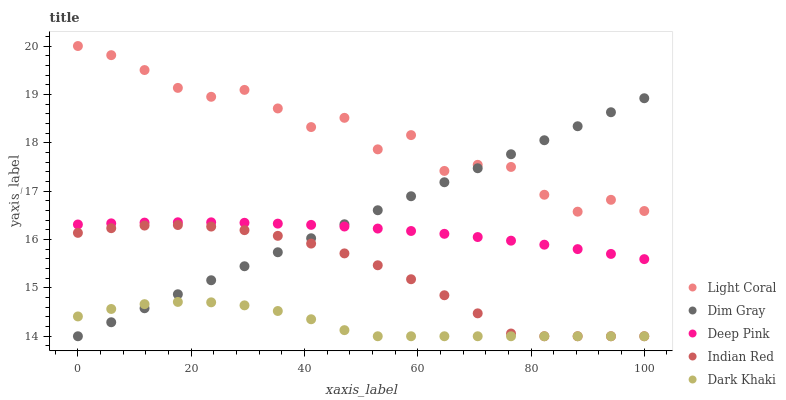Does Dark Khaki have the minimum area under the curve?
Answer yes or no. Yes. Does Light Coral have the maximum area under the curve?
Answer yes or no. Yes. Does Dim Gray have the minimum area under the curve?
Answer yes or no. No. Does Dim Gray have the maximum area under the curve?
Answer yes or no. No. Is Dim Gray the smoothest?
Answer yes or no. Yes. Is Light Coral the roughest?
Answer yes or no. Yes. Is Dark Khaki the smoothest?
Answer yes or no. No. Is Dark Khaki the roughest?
Answer yes or no. No. Does Dark Khaki have the lowest value?
Answer yes or no. Yes. Does Deep Pink have the lowest value?
Answer yes or no. No. Does Light Coral have the highest value?
Answer yes or no. Yes. Does Dim Gray have the highest value?
Answer yes or no. No. Is Indian Red less than Deep Pink?
Answer yes or no. Yes. Is Light Coral greater than Indian Red?
Answer yes or no. Yes. Does Indian Red intersect Dark Khaki?
Answer yes or no. Yes. Is Indian Red less than Dark Khaki?
Answer yes or no. No. Is Indian Red greater than Dark Khaki?
Answer yes or no. No. Does Indian Red intersect Deep Pink?
Answer yes or no. No. 